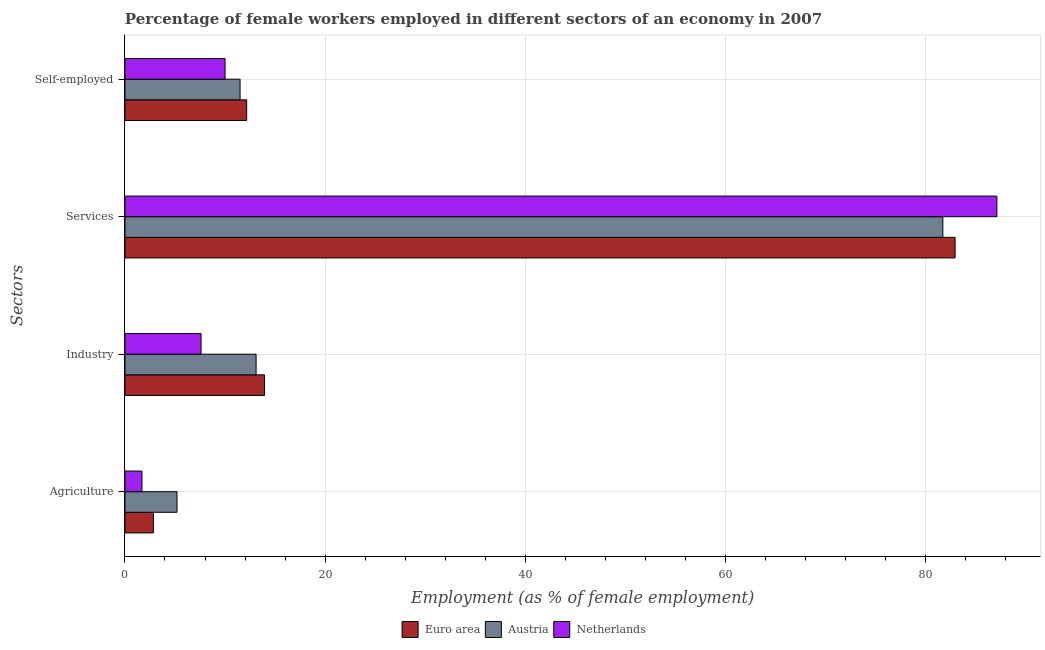Are the number of bars per tick equal to the number of legend labels?
Give a very brief answer. Yes. What is the label of the 1st group of bars from the top?
Your answer should be compact. Self-employed. What is the percentage of self employed female workers in Euro area?
Ensure brevity in your answer.  12.16. Across all countries, what is the maximum percentage of female workers in agriculture?
Your answer should be very brief. 5.2. Across all countries, what is the minimum percentage of female workers in services?
Give a very brief answer. 81.7. What is the total percentage of female workers in services in the graph?
Offer a terse response. 251.72. What is the difference between the percentage of self employed female workers in Austria and that in Euro area?
Give a very brief answer. -0.66. What is the difference between the percentage of female workers in industry in Austria and the percentage of female workers in services in Euro area?
Offer a terse response. -69.82. What is the average percentage of female workers in industry per country?
Your answer should be very brief. 11.55. What is the difference between the percentage of female workers in services and percentage of self employed female workers in Netherlands?
Keep it short and to the point. 77.1. In how many countries, is the percentage of female workers in services greater than 36 %?
Give a very brief answer. 3. What is the ratio of the percentage of female workers in agriculture in Austria to that in Euro area?
Provide a succinct answer. 1.83. Is the difference between the percentage of self employed female workers in Austria and Euro area greater than the difference between the percentage of female workers in services in Austria and Euro area?
Your response must be concise. Yes. What is the difference between the highest and the second highest percentage of female workers in agriculture?
Give a very brief answer. 2.36. What is the difference between the highest and the lowest percentage of female workers in industry?
Give a very brief answer. 6.34. Is it the case that in every country, the sum of the percentage of female workers in services and percentage of female workers in industry is greater than the sum of percentage of self employed female workers and percentage of female workers in agriculture?
Keep it short and to the point. No. What does the 2nd bar from the top in Industry represents?
Give a very brief answer. Austria. Is it the case that in every country, the sum of the percentage of female workers in agriculture and percentage of female workers in industry is greater than the percentage of female workers in services?
Provide a short and direct response. No. How many countries are there in the graph?
Your answer should be compact. 3. What is the difference between two consecutive major ticks on the X-axis?
Keep it short and to the point. 20. Does the graph contain any zero values?
Ensure brevity in your answer.  No. How many legend labels are there?
Your response must be concise. 3. What is the title of the graph?
Give a very brief answer. Percentage of female workers employed in different sectors of an economy in 2007. Does "Iran" appear as one of the legend labels in the graph?
Make the answer very short. No. What is the label or title of the X-axis?
Give a very brief answer. Employment (as % of female employment). What is the label or title of the Y-axis?
Offer a very short reply. Sectors. What is the Employment (as % of female employment) in Euro area in Agriculture?
Provide a short and direct response. 2.84. What is the Employment (as % of female employment) of Austria in Agriculture?
Your answer should be very brief. 5.2. What is the Employment (as % of female employment) in Netherlands in Agriculture?
Ensure brevity in your answer.  1.7. What is the Employment (as % of female employment) in Euro area in Industry?
Your answer should be very brief. 13.94. What is the Employment (as % of female employment) in Austria in Industry?
Provide a short and direct response. 13.1. What is the Employment (as % of female employment) in Netherlands in Industry?
Make the answer very short. 7.6. What is the Employment (as % of female employment) in Euro area in Services?
Your answer should be very brief. 82.92. What is the Employment (as % of female employment) of Austria in Services?
Offer a terse response. 81.7. What is the Employment (as % of female employment) of Netherlands in Services?
Offer a terse response. 87.1. What is the Employment (as % of female employment) in Euro area in Self-employed?
Offer a terse response. 12.16. What is the Employment (as % of female employment) in Austria in Self-employed?
Make the answer very short. 11.5. What is the Employment (as % of female employment) in Netherlands in Self-employed?
Offer a very short reply. 10. Across all Sectors, what is the maximum Employment (as % of female employment) of Euro area?
Offer a very short reply. 82.92. Across all Sectors, what is the maximum Employment (as % of female employment) in Austria?
Keep it short and to the point. 81.7. Across all Sectors, what is the maximum Employment (as % of female employment) of Netherlands?
Give a very brief answer. 87.1. Across all Sectors, what is the minimum Employment (as % of female employment) in Euro area?
Provide a succinct answer. 2.84. Across all Sectors, what is the minimum Employment (as % of female employment) of Austria?
Give a very brief answer. 5.2. Across all Sectors, what is the minimum Employment (as % of female employment) of Netherlands?
Make the answer very short. 1.7. What is the total Employment (as % of female employment) of Euro area in the graph?
Keep it short and to the point. 111.87. What is the total Employment (as % of female employment) in Austria in the graph?
Provide a succinct answer. 111.5. What is the total Employment (as % of female employment) of Netherlands in the graph?
Provide a succinct answer. 106.4. What is the difference between the Employment (as % of female employment) in Euro area in Agriculture and that in Industry?
Your response must be concise. -11.1. What is the difference between the Employment (as % of female employment) of Austria in Agriculture and that in Industry?
Provide a succinct answer. -7.9. What is the difference between the Employment (as % of female employment) in Euro area in Agriculture and that in Services?
Your response must be concise. -80.08. What is the difference between the Employment (as % of female employment) in Austria in Agriculture and that in Services?
Provide a short and direct response. -76.5. What is the difference between the Employment (as % of female employment) in Netherlands in Agriculture and that in Services?
Your answer should be compact. -85.4. What is the difference between the Employment (as % of female employment) of Euro area in Agriculture and that in Self-employed?
Keep it short and to the point. -9.31. What is the difference between the Employment (as % of female employment) of Netherlands in Agriculture and that in Self-employed?
Ensure brevity in your answer.  -8.3. What is the difference between the Employment (as % of female employment) in Euro area in Industry and that in Services?
Offer a terse response. -68.98. What is the difference between the Employment (as % of female employment) of Austria in Industry and that in Services?
Ensure brevity in your answer.  -68.6. What is the difference between the Employment (as % of female employment) in Netherlands in Industry and that in Services?
Provide a succinct answer. -79.5. What is the difference between the Employment (as % of female employment) in Euro area in Industry and that in Self-employed?
Your answer should be very brief. 1.78. What is the difference between the Employment (as % of female employment) in Netherlands in Industry and that in Self-employed?
Your response must be concise. -2.4. What is the difference between the Employment (as % of female employment) in Euro area in Services and that in Self-employed?
Make the answer very short. 70.77. What is the difference between the Employment (as % of female employment) in Austria in Services and that in Self-employed?
Provide a short and direct response. 70.2. What is the difference between the Employment (as % of female employment) of Netherlands in Services and that in Self-employed?
Offer a very short reply. 77.1. What is the difference between the Employment (as % of female employment) of Euro area in Agriculture and the Employment (as % of female employment) of Austria in Industry?
Keep it short and to the point. -10.26. What is the difference between the Employment (as % of female employment) of Euro area in Agriculture and the Employment (as % of female employment) of Netherlands in Industry?
Give a very brief answer. -4.76. What is the difference between the Employment (as % of female employment) of Euro area in Agriculture and the Employment (as % of female employment) of Austria in Services?
Give a very brief answer. -78.86. What is the difference between the Employment (as % of female employment) in Euro area in Agriculture and the Employment (as % of female employment) in Netherlands in Services?
Offer a terse response. -84.26. What is the difference between the Employment (as % of female employment) of Austria in Agriculture and the Employment (as % of female employment) of Netherlands in Services?
Your response must be concise. -81.9. What is the difference between the Employment (as % of female employment) in Euro area in Agriculture and the Employment (as % of female employment) in Austria in Self-employed?
Your answer should be compact. -8.66. What is the difference between the Employment (as % of female employment) in Euro area in Agriculture and the Employment (as % of female employment) in Netherlands in Self-employed?
Provide a short and direct response. -7.16. What is the difference between the Employment (as % of female employment) of Austria in Agriculture and the Employment (as % of female employment) of Netherlands in Self-employed?
Your answer should be very brief. -4.8. What is the difference between the Employment (as % of female employment) of Euro area in Industry and the Employment (as % of female employment) of Austria in Services?
Offer a very short reply. -67.76. What is the difference between the Employment (as % of female employment) in Euro area in Industry and the Employment (as % of female employment) in Netherlands in Services?
Your response must be concise. -73.16. What is the difference between the Employment (as % of female employment) in Austria in Industry and the Employment (as % of female employment) in Netherlands in Services?
Make the answer very short. -74. What is the difference between the Employment (as % of female employment) of Euro area in Industry and the Employment (as % of female employment) of Austria in Self-employed?
Provide a short and direct response. 2.44. What is the difference between the Employment (as % of female employment) in Euro area in Industry and the Employment (as % of female employment) in Netherlands in Self-employed?
Ensure brevity in your answer.  3.94. What is the difference between the Employment (as % of female employment) in Euro area in Services and the Employment (as % of female employment) in Austria in Self-employed?
Keep it short and to the point. 71.42. What is the difference between the Employment (as % of female employment) of Euro area in Services and the Employment (as % of female employment) of Netherlands in Self-employed?
Provide a short and direct response. 72.92. What is the difference between the Employment (as % of female employment) in Austria in Services and the Employment (as % of female employment) in Netherlands in Self-employed?
Provide a succinct answer. 71.7. What is the average Employment (as % of female employment) of Euro area per Sectors?
Your response must be concise. 27.97. What is the average Employment (as % of female employment) of Austria per Sectors?
Your answer should be very brief. 27.88. What is the average Employment (as % of female employment) in Netherlands per Sectors?
Offer a terse response. 26.6. What is the difference between the Employment (as % of female employment) in Euro area and Employment (as % of female employment) in Austria in Agriculture?
Provide a succinct answer. -2.36. What is the difference between the Employment (as % of female employment) of Euro area and Employment (as % of female employment) of Netherlands in Agriculture?
Provide a succinct answer. 1.14. What is the difference between the Employment (as % of female employment) in Euro area and Employment (as % of female employment) in Austria in Industry?
Your response must be concise. 0.84. What is the difference between the Employment (as % of female employment) in Euro area and Employment (as % of female employment) in Netherlands in Industry?
Provide a succinct answer. 6.34. What is the difference between the Employment (as % of female employment) of Austria and Employment (as % of female employment) of Netherlands in Industry?
Give a very brief answer. 5.5. What is the difference between the Employment (as % of female employment) of Euro area and Employment (as % of female employment) of Austria in Services?
Your response must be concise. 1.22. What is the difference between the Employment (as % of female employment) of Euro area and Employment (as % of female employment) of Netherlands in Services?
Your response must be concise. -4.18. What is the difference between the Employment (as % of female employment) of Euro area and Employment (as % of female employment) of Austria in Self-employed?
Offer a terse response. 0.66. What is the difference between the Employment (as % of female employment) in Euro area and Employment (as % of female employment) in Netherlands in Self-employed?
Ensure brevity in your answer.  2.16. What is the difference between the Employment (as % of female employment) in Austria and Employment (as % of female employment) in Netherlands in Self-employed?
Your answer should be very brief. 1.5. What is the ratio of the Employment (as % of female employment) in Euro area in Agriculture to that in Industry?
Give a very brief answer. 0.2. What is the ratio of the Employment (as % of female employment) in Austria in Agriculture to that in Industry?
Your answer should be very brief. 0.4. What is the ratio of the Employment (as % of female employment) in Netherlands in Agriculture to that in Industry?
Offer a very short reply. 0.22. What is the ratio of the Employment (as % of female employment) in Euro area in Agriculture to that in Services?
Your answer should be very brief. 0.03. What is the ratio of the Employment (as % of female employment) in Austria in Agriculture to that in Services?
Give a very brief answer. 0.06. What is the ratio of the Employment (as % of female employment) of Netherlands in Agriculture to that in Services?
Provide a short and direct response. 0.02. What is the ratio of the Employment (as % of female employment) in Euro area in Agriculture to that in Self-employed?
Your answer should be very brief. 0.23. What is the ratio of the Employment (as % of female employment) of Austria in Agriculture to that in Self-employed?
Give a very brief answer. 0.45. What is the ratio of the Employment (as % of female employment) in Netherlands in Agriculture to that in Self-employed?
Your answer should be compact. 0.17. What is the ratio of the Employment (as % of female employment) of Euro area in Industry to that in Services?
Your response must be concise. 0.17. What is the ratio of the Employment (as % of female employment) of Austria in Industry to that in Services?
Ensure brevity in your answer.  0.16. What is the ratio of the Employment (as % of female employment) in Netherlands in Industry to that in Services?
Provide a succinct answer. 0.09. What is the ratio of the Employment (as % of female employment) in Euro area in Industry to that in Self-employed?
Keep it short and to the point. 1.15. What is the ratio of the Employment (as % of female employment) of Austria in Industry to that in Self-employed?
Keep it short and to the point. 1.14. What is the ratio of the Employment (as % of female employment) of Netherlands in Industry to that in Self-employed?
Make the answer very short. 0.76. What is the ratio of the Employment (as % of female employment) in Euro area in Services to that in Self-employed?
Keep it short and to the point. 6.82. What is the ratio of the Employment (as % of female employment) in Austria in Services to that in Self-employed?
Keep it short and to the point. 7.1. What is the ratio of the Employment (as % of female employment) in Netherlands in Services to that in Self-employed?
Provide a succinct answer. 8.71. What is the difference between the highest and the second highest Employment (as % of female employment) of Euro area?
Your answer should be very brief. 68.98. What is the difference between the highest and the second highest Employment (as % of female employment) in Austria?
Offer a terse response. 68.6. What is the difference between the highest and the second highest Employment (as % of female employment) in Netherlands?
Keep it short and to the point. 77.1. What is the difference between the highest and the lowest Employment (as % of female employment) of Euro area?
Your response must be concise. 80.08. What is the difference between the highest and the lowest Employment (as % of female employment) of Austria?
Keep it short and to the point. 76.5. What is the difference between the highest and the lowest Employment (as % of female employment) in Netherlands?
Offer a very short reply. 85.4. 